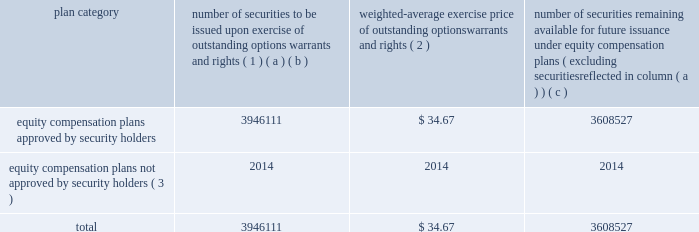Equity compensation plan information the table presents the equity securities available for issuance under our equity compensation plans as of december 31 , 2012 .
Equity compensation plan information plan category number of securities to be issued upon exercise of outstanding options , warrants and rights ( 1 ) weighted-average exercise price of outstanding options , warrants and rights ( 2 ) number of securities remaining available for future issuance under equity compensation plans ( excluding securities reflected in column ( a ) ) ( a ) ( b ) ( c ) equity compensation plans approved by security holders 3946111 $ 34.67 3608527 equity compensation plans not approved by security holders ( 3 ) 2014 2014 2014 .
( 1 ) includes grants made under the huntington ingalls industries , inc .
2012 long-term incentive stock plan ( the "2012 plan" ) , which was approved by our stockholders on may 2 , 2012 , and the huntington ingalls industries , inc .
2011 long-term incentive stock plan ( the "2011 plan" ) , which was approved by the sole stockholder of hii prior to its spin-off from northrop grumman corporation .
Of these shares , 1166492 were subject to stock options , 2060138 were subject to outstanding restricted performance stock rights , 641556 were restricted stock rights , and 63033 were stock rights granted under the 2011 plan .
In addition , this number includes 9129 stock rights and 5763 restricted performance stock rights granted under the 2012 plan , assuming target performance achievement .
( 2 ) this is the weighted average exercise price of the 1166492 outstanding stock options only .
( 3 ) there are no awards made under plans not approved by security holders .
Item 13 .
Certain relationships and related transactions , and director independence information as to certain relationships and related transactions and director independence will be incorporated herein by reference to the proxy statement for our 2013 annual meeting of stockholders to be filed within 120 days after the end of the company 2019s fiscal year .
Item 14 .
Principal accountant fees and services information as to principal accountant fees and services will be incorporated herein by reference to the proxy statement for our 2013 annual meeting of stockholders to be filed within 120 days after the end of the company 2019s fiscal year. .
What is the ratio of the number of securities to be issued to the number of securities remaining available? 
Rationale: for every 1.1 securities to be issued there is 1 securities remaining
Computations: (3946111 / 3608527)
Answer: 1.09355. Equity compensation plan information the table presents the equity securities available for issuance under our equity compensation plans as of december 31 , 2012 .
Equity compensation plan information plan category number of securities to be issued upon exercise of outstanding options , warrants and rights ( 1 ) weighted-average exercise price of outstanding options , warrants and rights ( 2 ) number of securities remaining available for future issuance under equity compensation plans ( excluding securities reflected in column ( a ) ) ( a ) ( b ) ( c ) equity compensation plans approved by security holders 3946111 $ 34.67 3608527 equity compensation plans not approved by security holders ( 3 ) 2014 2014 2014 .
( 1 ) includes grants made under the huntington ingalls industries , inc .
2012 long-term incentive stock plan ( the "2012 plan" ) , which was approved by our stockholders on may 2 , 2012 , and the huntington ingalls industries , inc .
2011 long-term incentive stock plan ( the "2011 plan" ) , which was approved by the sole stockholder of hii prior to its spin-off from northrop grumman corporation .
Of these shares , 1166492 were subject to stock options , 2060138 were subject to outstanding restricted performance stock rights , 641556 were restricted stock rights , and 63033 were stock rights granted under the 2011 plan .
In addition , this number includes 9129 stock rights and 5763 restricted performance stock rights granted under the 2012 plan , assuming target performance achievement .
( 2 ) this is the weighted average exercise price of the 1166492 outstanding stock options only .
( 3 ) there are no awards made under plans not approved by security holders .
Item 13 .
Certain relationships and related transactions , and director independence information as to certain relationships and related transactions and director independence will be incorporated herein by reference to the proxy statement for our 2013 annual meeting of stockholders to be filed within 120 days after the end of the company 2019s fiscal year .
Item 14 .
Principal accountant fees and services information as to principal accountant fees and services will be incorporated herein by reference to the proxy statement for our 2013 annual meeting of stockholders to be filed within 120 days after the end of the company 2019s fiscal year. .
What is the total equity compensation plans approved by security holders? 
Rationale: the total is the sum of all securities for the plan
Computations: (3946111 + 3608527)
Answer: 7554638.0. 